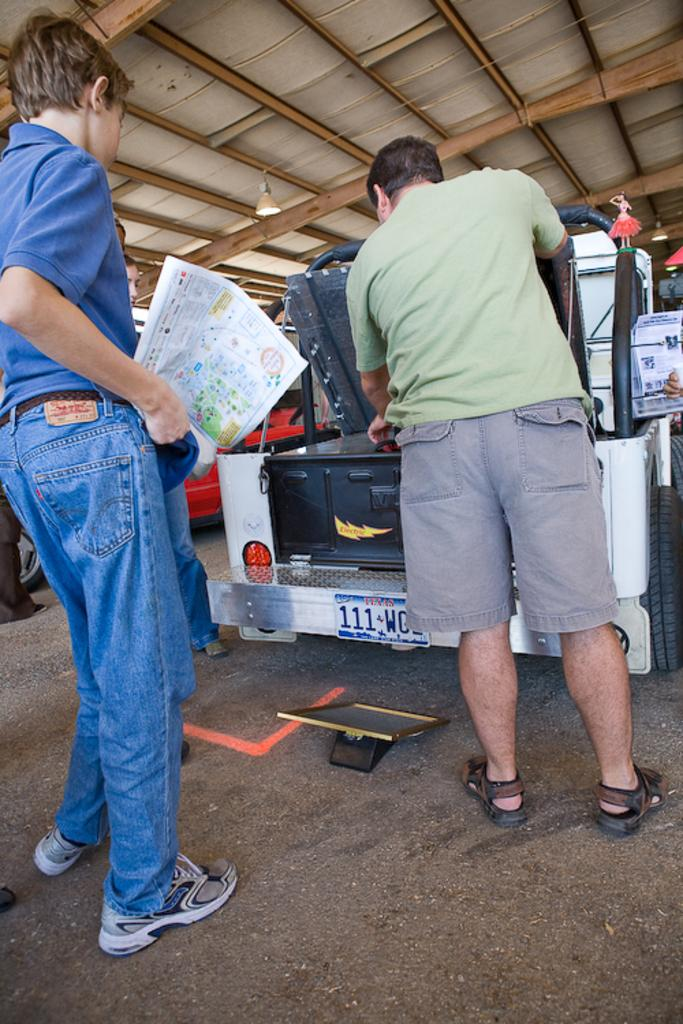How many people are in the foreground of the image? There are two people standing in the foreground of the image. What else can be seen in the image besides the people in the foreground? There is a vehicle in the image. Are there any other people visible in the image? Yes, there are other people standing near the vehicle. What type of rose is being held by the creature in the image? There is no rose or creature present in the image. 